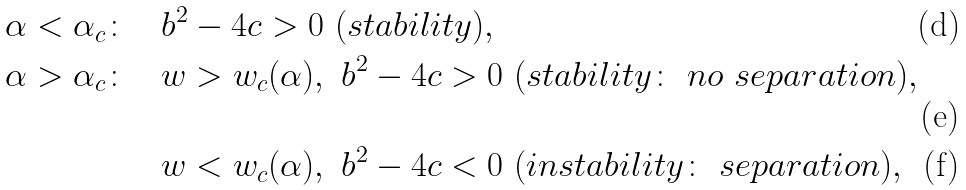Convert formula to latex. <formula><loc_0><loc_0><loc_500><loc_500>& \alpha < \alpha _ { c } \colon \ & & b ^ { 2 } - 4 c > 0 \ ( s t a b i l i t y ) , \\ & \alpha > \alpha _ { c } \colon \ & & w > w _ { c } ( \alpha ) , \ b ^ { 2 } - 4 c > 0 \ ( s t a b i l i t y \colon \ n o \ s e p a r a t i o n ) , \\ & & & w < w _ { c } ( \alpha ) , \ b ^ { 2 } - 4 c < 0 \ ( i n s t a b i l i t y \colon \ s e p a r a t i o n ) ,</formula> 